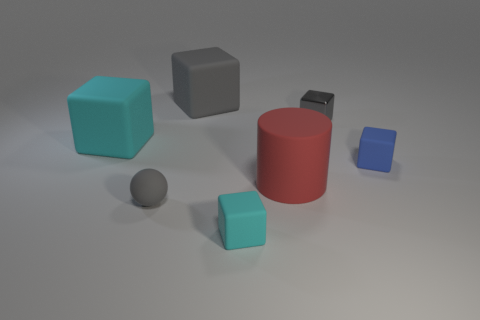Subtract all tiny cubes. How many cubes are left? 2 Subtract 2 cubes. How many cubes are left? 3 Subtract all gray blocks. How many blocks are left? 3 Add 3 large gray matte cubes. How many objects exist? 10 Subtract all red blocks. Subtract all green cylinders. How many blocks are left? 5 Subtract all blocks. How many objects are left? 2 Add 1 tiny matte cubes. How many tiny matte cubes are left? 3 Add 5 tiny gray matte things. How many tiny gray matte things exist? 6 Subtract 0 yellow spheres. How many objects are left? 7 Subtract all red rubber objects. Subtract all small blue objects. How many objects are left? 5 